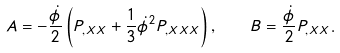Convert formula to latex. <formula><loc_0><loc_0><loc_500><loc_500>A = - \frac { \dot { \phi } } { 2 } \left ( P _ { , X X } + \frac { 1 } { 3 } \dot { \phi } ^ { 2 } P _ { , X X X } \right ) , \quad B = \frac { \dot { \phi } } { 2 } P _ { , X X } .</formula> 